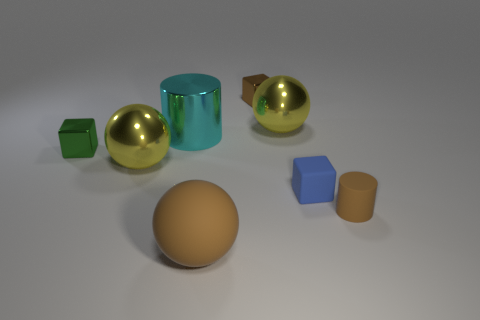Add 1 big yellow metal spheres. How many objects exist? 9 Subtract all blocks. How many objects are left? 5 Add 5 cylinders. How many cylinders are left? 7 Add 7 big purple metallic cylinders. How many big purple metallic cylinders exist? 7 Subtract 1 brown balls. How many objects are left? 7 Subtract all large blue things. Subtract all small cylinders. How many objects are left? 7 